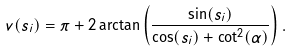<formula> <loc_0><loc_0><loc_500><loc_500>v ( s _ { i } ) = \pi + 2 \arctan \left ( \frac { \sin ( s _ { i } ) } { \cos ( s _ { i } ) + \cot ^ { 2 } ( \alpha ) } \right ) .</formula> 